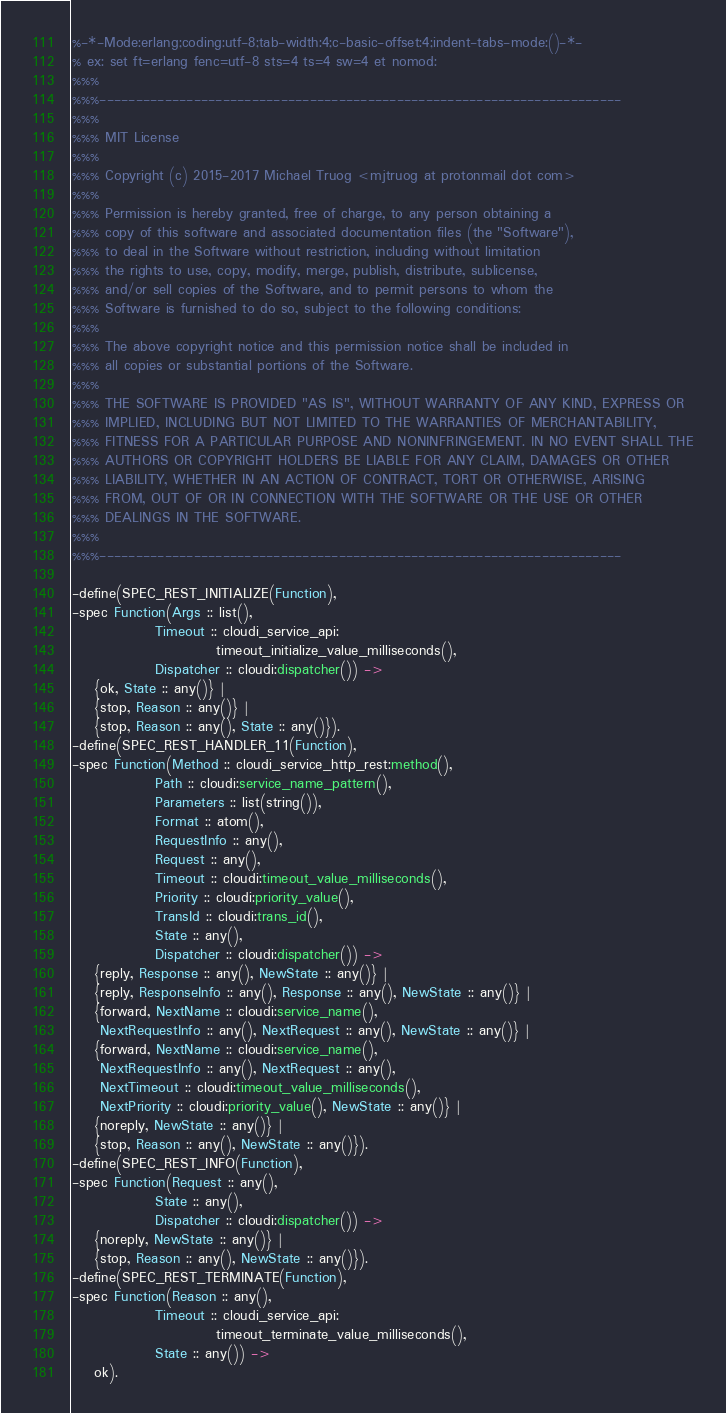Convert code to text. <code><loc_0><loc_0><loc_500><loc_500><_Erlang_>%-*-Mode:erlang;coding:utf-8;tab-width:4;c-basic-offset:4;indent-tabs-mode:()-*-
% ex: set ft=erlang fenc=utf-8 sts=4 ts=4 sw=4 et nomod:
%%%
%%%------------------------------------------------------------------------
%%%
%%% MIT License
%%%
%%% Copyright (c) 2015-2017 Michael Truog <mjtruog at protonmail dot com>
%%%
%%% Permission is hereby granted, free of charge, to any person obtaining a
%%% copy of this software and associated documentation files (the "Software"),
%%% to deal in the Software without restriction, including without limitation
%%% the rights to use, copy, modify, merge, publish, distribute, sublicense,
%%% and/or sell copies of the Software, and to permit persons to whom the
%%% Software is furnished to do so, subject to the following conditions:
%%%
%%% The above copyright notice and this permission notice shall be included in
%%% all copies or substantial portions of the Software.
%%%
%%% THE SOFTWARE IS PROVIDED "AS IS", WITHOUT WARRANTY OF ANY KIND, EXPRESS OR
%%% IMPLIED, INCLUDING BUT NOT LIMITED TO THE WARRANTIES OF MERCHANTABILITY,
%%% FITNESS FOR A PARTICULAR PURPOSE AND NONINFRINGEMENT. IN NO EVENT SHALL THE
%%% AUTHORS OR COPYRIGHT HOLDERS BE LIABLE FOR ANY CLAIM, DAMAGES OR OTHER
%%% LIABILITY, WHETHER IN AN ACTION OF CONTRACT, TORT OR OTHERWISE, ARISING
%%% FROM, OUT OF OR IN CONNECTION WITH THE SOFTWARE OR THE USE OR OTHER
%%% DEALINGS IN THE SOFTWARE.
%%%
%%%------------------------------------------------------------------------

-define(SPEC_REST_INITIALIZE(Function),
-spec Function(Args :: list(),
               Timeout :: cloudi_service_api:
                          timeout_initialize_value_milliseconds(),
               Dispatcher :: cloudi:dispatcher()) ->
    {ok, State :: any()} |
    {stop, Reason :: any()} |
    {stop, Reason :: any(), State :: any()}).
-define(SPEC_REST_HANDLER_11(Function),
-spec Function(Method :: cloudi_service_http_rest:method(),
               Path :: cloudi:service_name_pattern(),
               Parameters :: list(string()),
               Format :: atom(),
               RequestInfo :: any(),
               Request :: any(),
               Timeout :: cloudi:timeout_value_milliseconds(),
               Priority :: cloudi:priority_value(),
               TransId :: cloudi:trans_id(),
               State :: any(),
               Dispatcher :: cloudi:dispatcher()) ->
    {reply, Response :: any(), NewState :: any()} |
    {reply, ResponseInfo :: any(), Response :: any(), NewState :: any()} |
    {forward, NextName :: cloudi:service_name(),
     NextRequestInfo :: any(), NextRequest :: any(), NewState :: any()} |
    {forward, NextName :: cloudi:service_name(),
     NextRequestInfo :: any(), NextRequest :: any(),
     NextTimeout :: cloudi:timeout_value_milliseconds(),
     NextPriority :: cloudi:priority_value(), NewState :: any()} |
    {noreply, NewState :: any()} |
    {stop, Reason :: any(), NewState :: any()}).
-define(SPEC_REST_INFO(Function),
-spec Function(Request :: any(),
               State :: any(),
               Dispatcher :: cloudi:dispatcher()) ->
    {noreply, NewState :: any()} |
    {stop, Reason :: any(), NewState :: any()}).
-define(SPEC_REST_TERMINATE(Function),
-spec Function(Reason :: any(),
               Timeout :: cloudi_service_api:
                          timeout_terminate_value_milliseconds(),
               State :: any()) ->
    ok).

</code> 